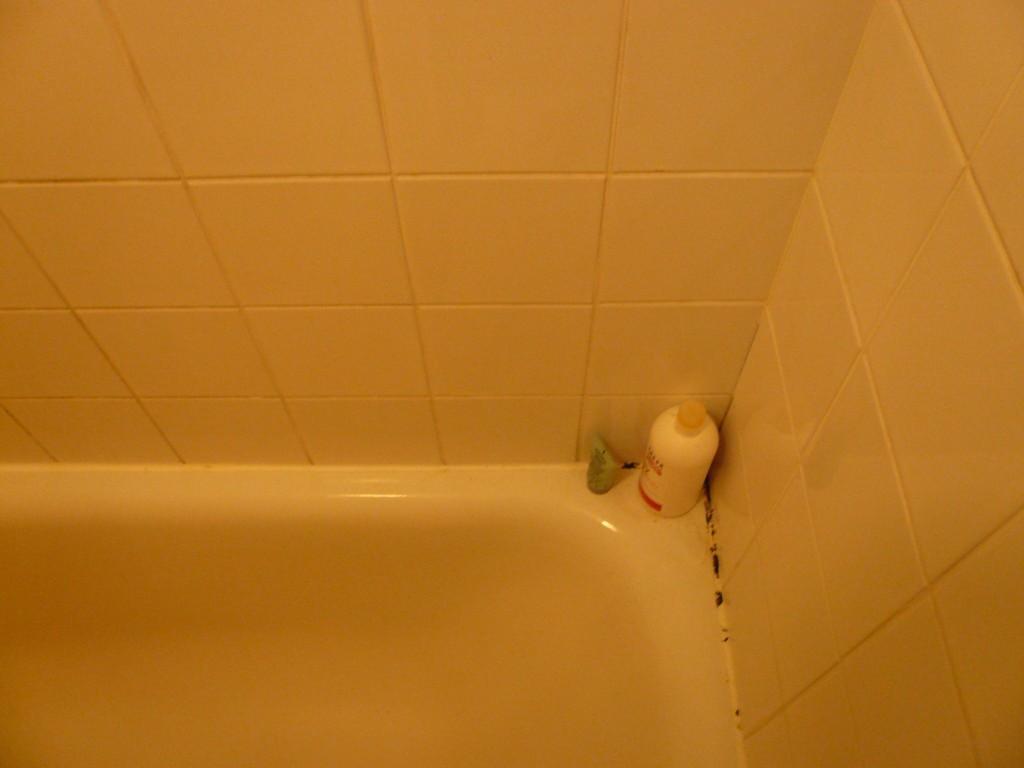In one or two sentences, can you explain what this image depicts? At the bottom of the image there is a bathtub. There is a bottle and a tube on the surface. And there is a wall with tiles. 